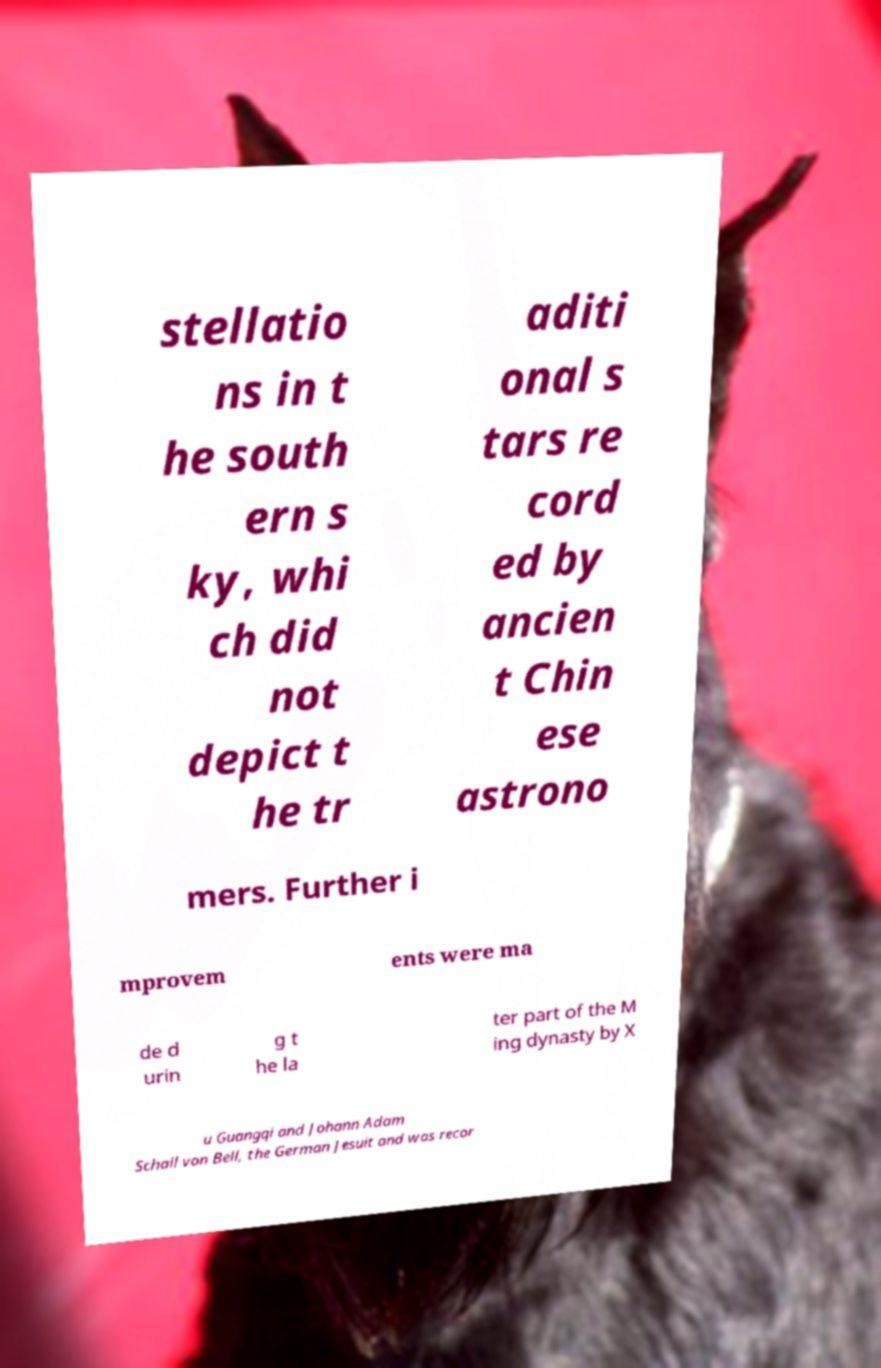There's text embedded in this image that I need extracted. Can you transcribe it verbatim? stellatio ns in t he south ern s ky, whi ch did not depict t he tr aditi onal s tars re cord ed by ancien t Chin ese astrono mers. Further i mprovem ents were ma de d urin g t he la ter part of the M ing dynasty by X u Guangqi and Johann Adam Schall von Bell, the German Jesuit and was recor 